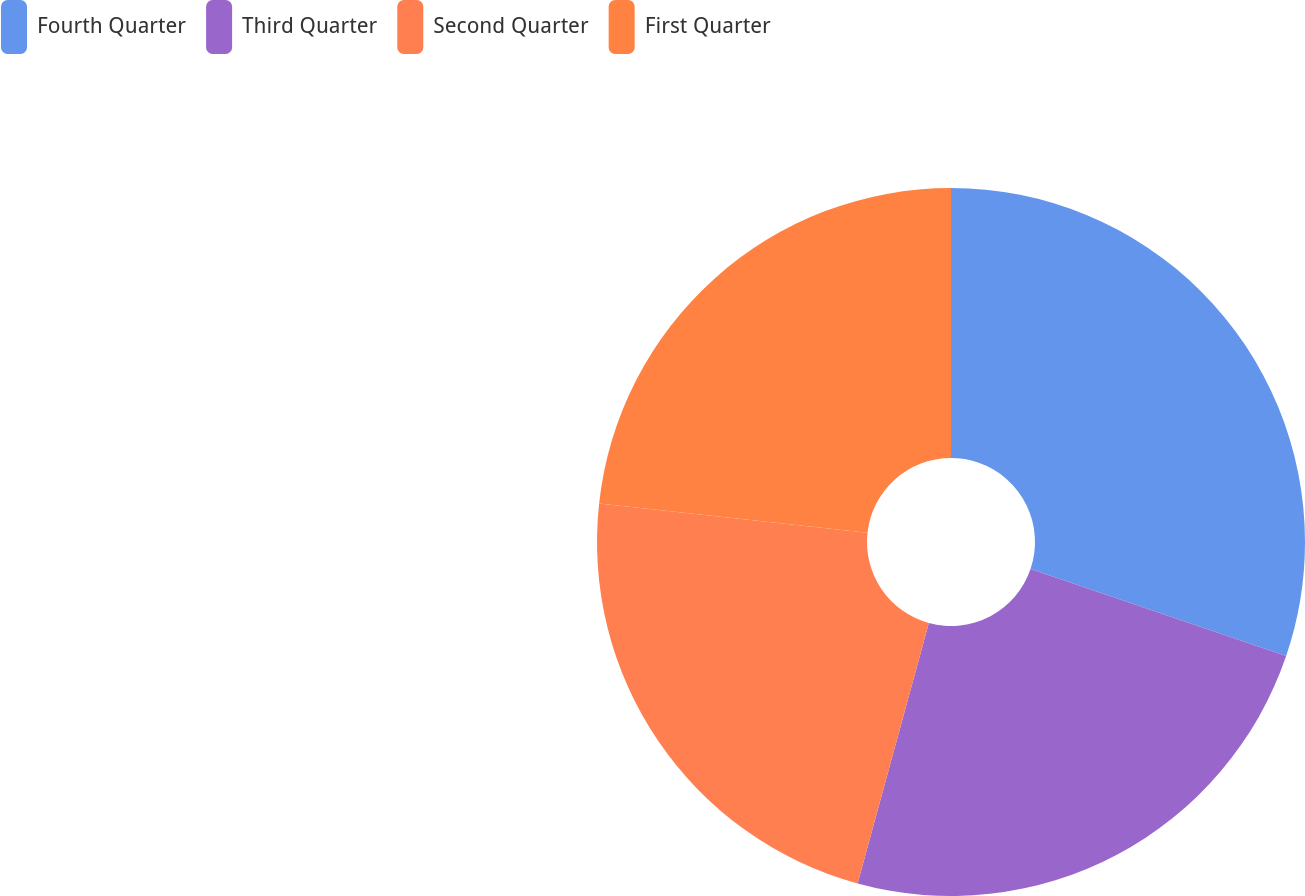<chart> <loc_0><loc_0><loc_500><loc_500><pie_chart><fcel>Fourth Quarter<fcel>Third Quarter<fcel>Second Quarter<fcel>First Quarter<nl><fcel>30.22%<fcel>24.03%<fcel>22.49%<fcel>23.26%<nl></chart> 